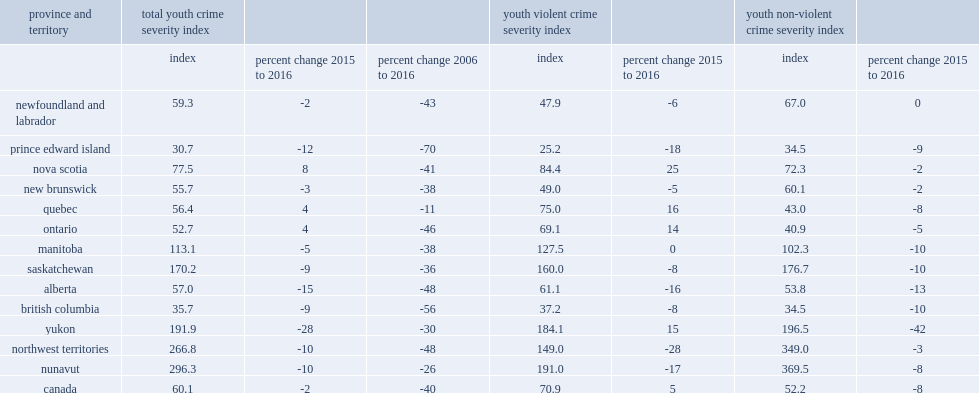Comparing to 2015, how many percentage point of youth csi has declined in yukon in 2016? 28. Comparing to 2015, how many percentage point of youth csi has declined in alberta in 2016? 15. Comparing to 2015, how many percentage point of youth csi has declined in prince edward island in 2016? 12. How many of youth csi per 100,000 population prince edward island has in 2016? 30.7. How many of youth csi per 100,000 population saskatchewan has in 2016? 170.2. How many of youth csi per 100,000 population manitoba has in 2016? 113.1. Comparing to 2015, how many percentage point of youth csi has increased in nova scotia in 2016? 8.0. Comparing to 2015, how many percentage point of youth csi has increased in ontario in 2016? 4.0. Comparing to 2015, how many percentage point of youth csi has increased in quebec in 2016? 4.0. 